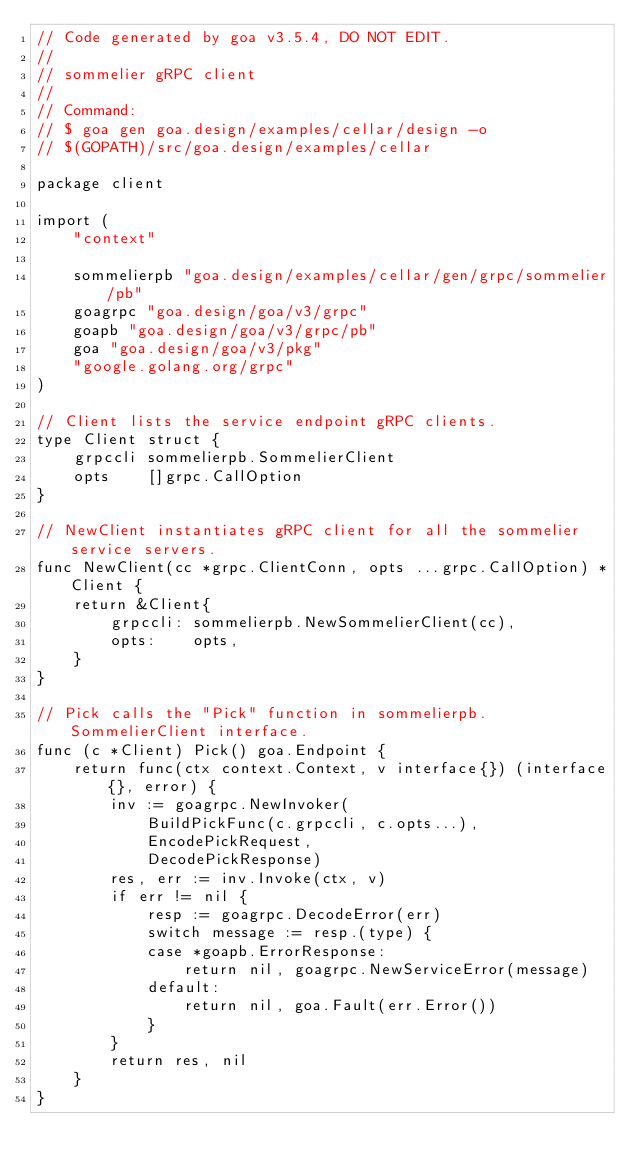<code> <loc_0><loc_0><loc_500><loc_500><_Go_>// Code generated by goa v3.5.4, DO NOT EDIT.
//
// sommelier gRPC client
//
// Command:
// $ goa gen goa.design/examples/cellar/design -o
// $(GOPATH)/src/goa.design/examples/cellar

package client

import (
	"context"

	sommelierpb "goa.design/examples/cellar/gen/grpc/sommelier/pb"
	goagrpc "goa.design/goa/v3/grpc"
	goapb "goa.design/goa/v3/grpc/pb"
	goa "goa.design/goa/v3/pkg"
	"google.golang.org/grpc"
)

// Client lists the service endpoint gRPC clients.
type Client struct {
	grpccli sommelierpb.SommelierClient
	opts    []grpc.CallOption
}

// NewClient instantiates gRPC client for all the sommelier service servers.
func NewClient(cc *grpc.ClientConn, opts ...grpc.CallOption) *Client {
	return &Client{
		grpccli: sommelierpb.NewSommelierClient(cc),
		opts:    opts,
	}
}

// Pick calls the "Pick" function in sommelierpb.SommelierClient interface.
func (c *Client) Pick() goa.Endpoint {
	return func(ctx context.Context, v interface{}) (interface{}, error) {
		inv := goagrpc.NewInvoker(
			BuildPickFunc(c.grpccli, c.opts...),
			EncodePickRequest,
			DecodePickResponse)
		res, err := inv.Invoke(ctx, v)
		if err != nil {
			resp := goagrpc.DecodeError(err)
			switch message := resp.(type) {
			case *goapb.ErrorResponse:
				return nil, goagrpc.NewServiceError(message)
			default:
				return nil, goa.Fault(err.Error())
			}
		}
		return res, nil
	}
}
</code> 